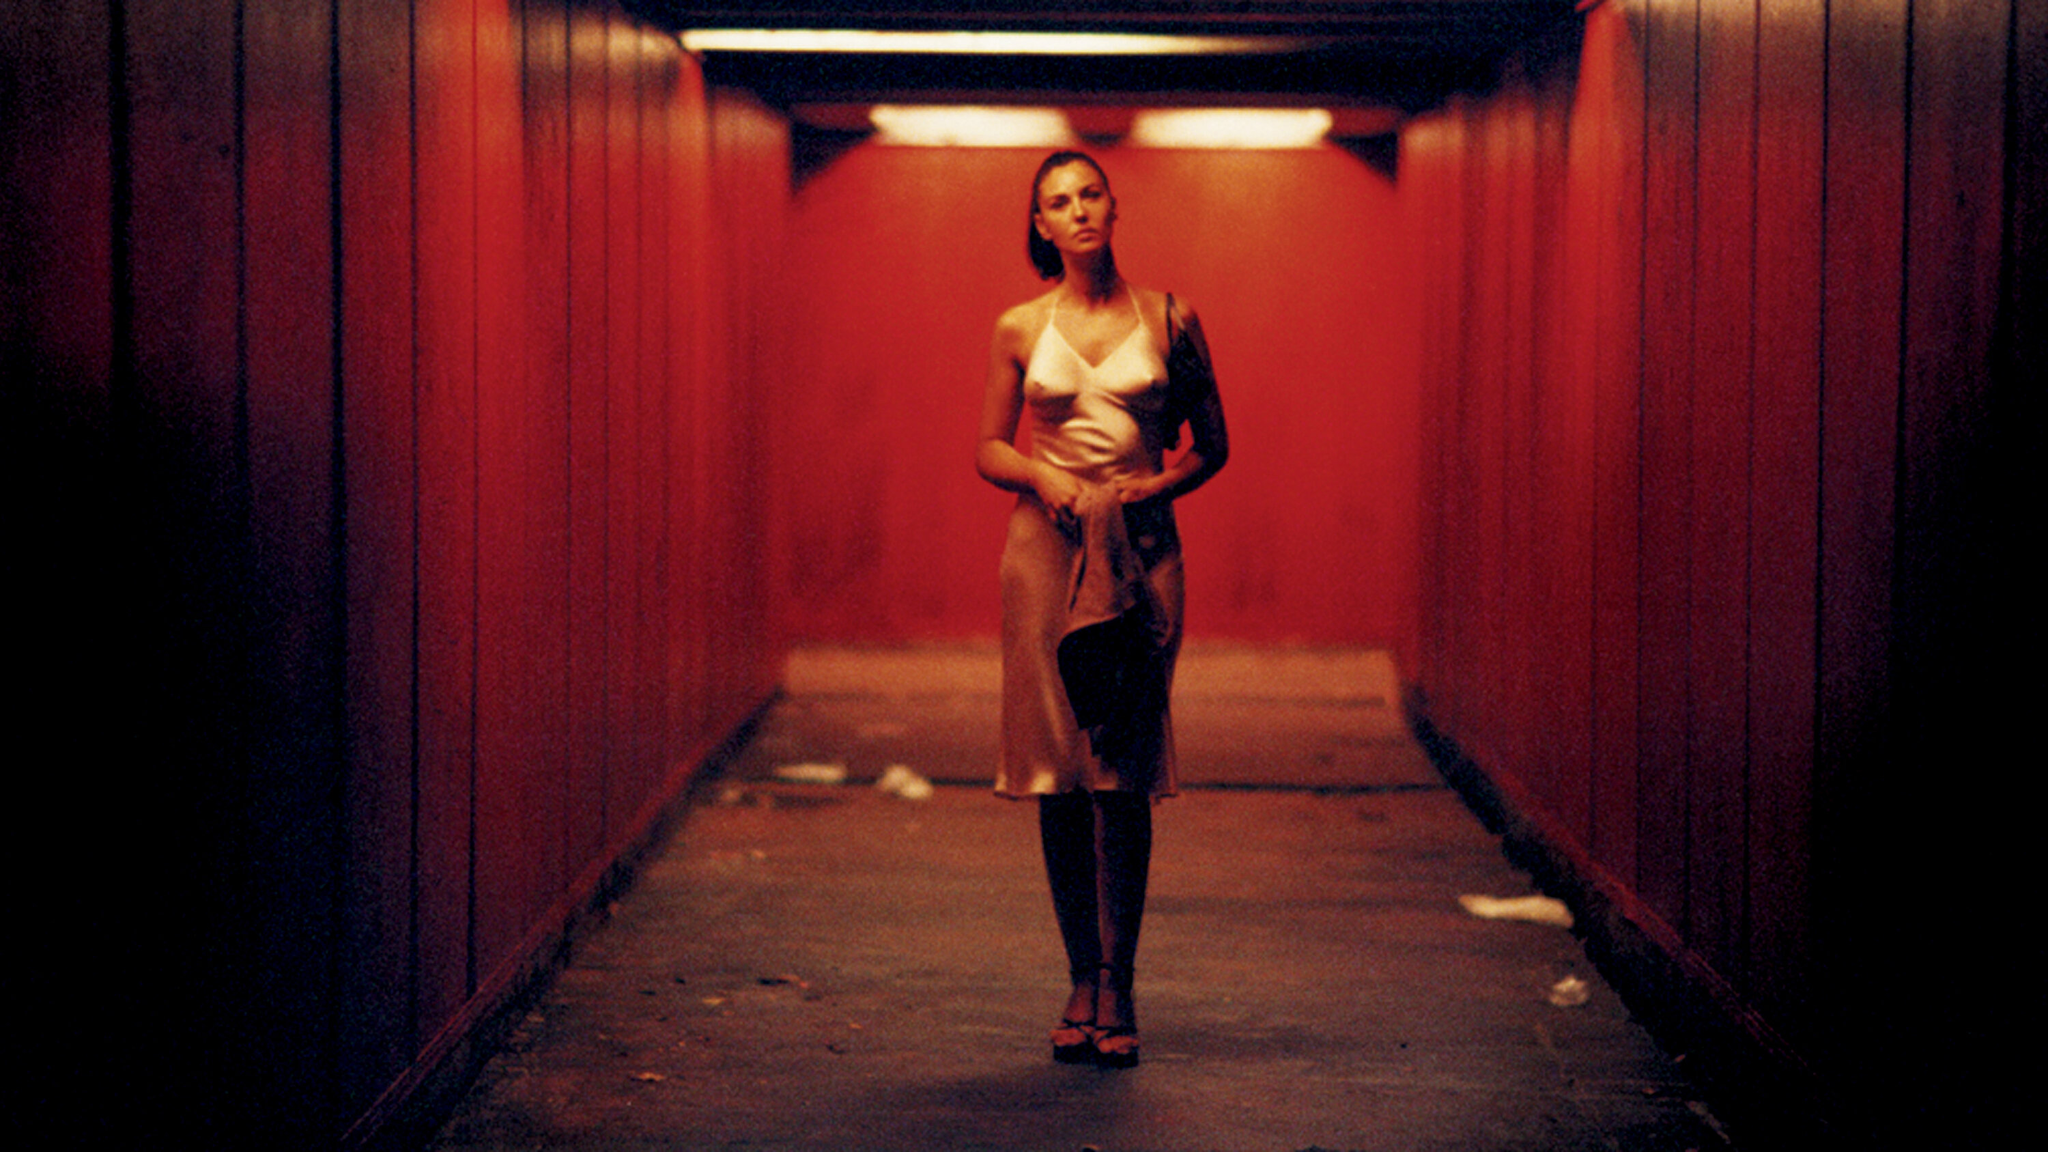Can you describe the impact of using red light in this composition? The red light in the composition intensifies the emotional weight of the image, casting the space in a dramatic and somewhat eerie glow. It illuminates the central figure, drawing the viewer's attention to her while also coloring the scene with an emotion that could be read as passion, danger, or deep introspection. How do you think the presence of litter in the tunnel affects the perception of the image? The litter scattered on the floor of the tunnel adds a layer of realism and grit to the image, contrasting with the elegance of the woman's attire. This juxtaposition between refinement and disarray emphasizes themes of contrast and perhaps comments on the duality of human experience—a visual discourse on finding grace amidst chaos. 